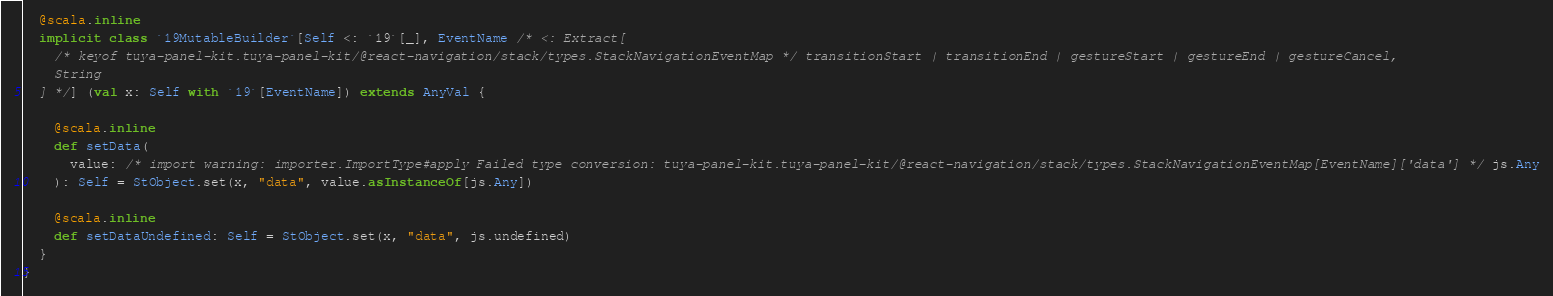<code> <loc_0><loc_0><loc_500><loc_500><_Scala_>  @scala.inline
  implicit class `19MutableBuilder`[Self <: `19`[_], EventName /* <: Extract[
    /* keyof tuya-panel-kit.tuya-panel-kit/@react-navigation/stack/types.StackNavigationEventMap */ transitionStart | transitionEnd | gestureStart | gestureEnd | gestureCancel, 
    String
  ] */] (val x: Self with `19`[EventName]) extends AnyVal {
    
    @scala.inline
    def setData(
      value: /* import warning: importer.ImportType#apply Failed type conversion: tuya-panel-kit.tuya-panel-kit/@react-navigation/stack/types.StackNavigationEventMap[EventName]['data'] */ js.Any
    ): Self = StObject.set(x, "data", value.asInstanceOf[js.Any])
    
    @scala.inline
    def setDataUndefined: Self = StObject.set(x, "data", js.undefined)
  }
}
</code> 